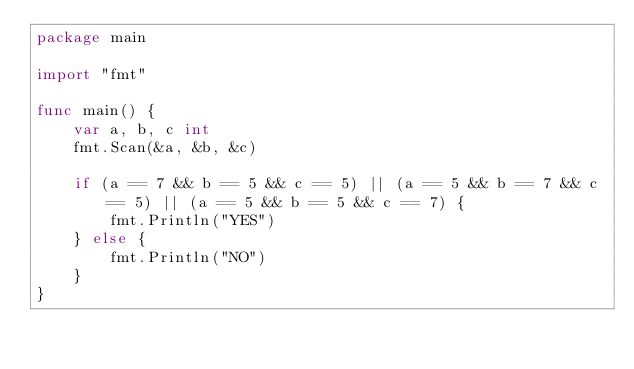<code> <loc_0><loc_0><loc_500><loc_500><_Go_>package main

import "fmt"

func main() {
	var a, b, c int
	fmt.Scan(&a, &b, &c)

	if (a == 7 && b == 5 && c == 5) || (a == 5 && b == 7 && c == 5) || (a == 5 && b == 5 && c == 7) {
		fmt.Println("YES")
	} else {
		fmt.Println("NO")
	}
}
</code> 